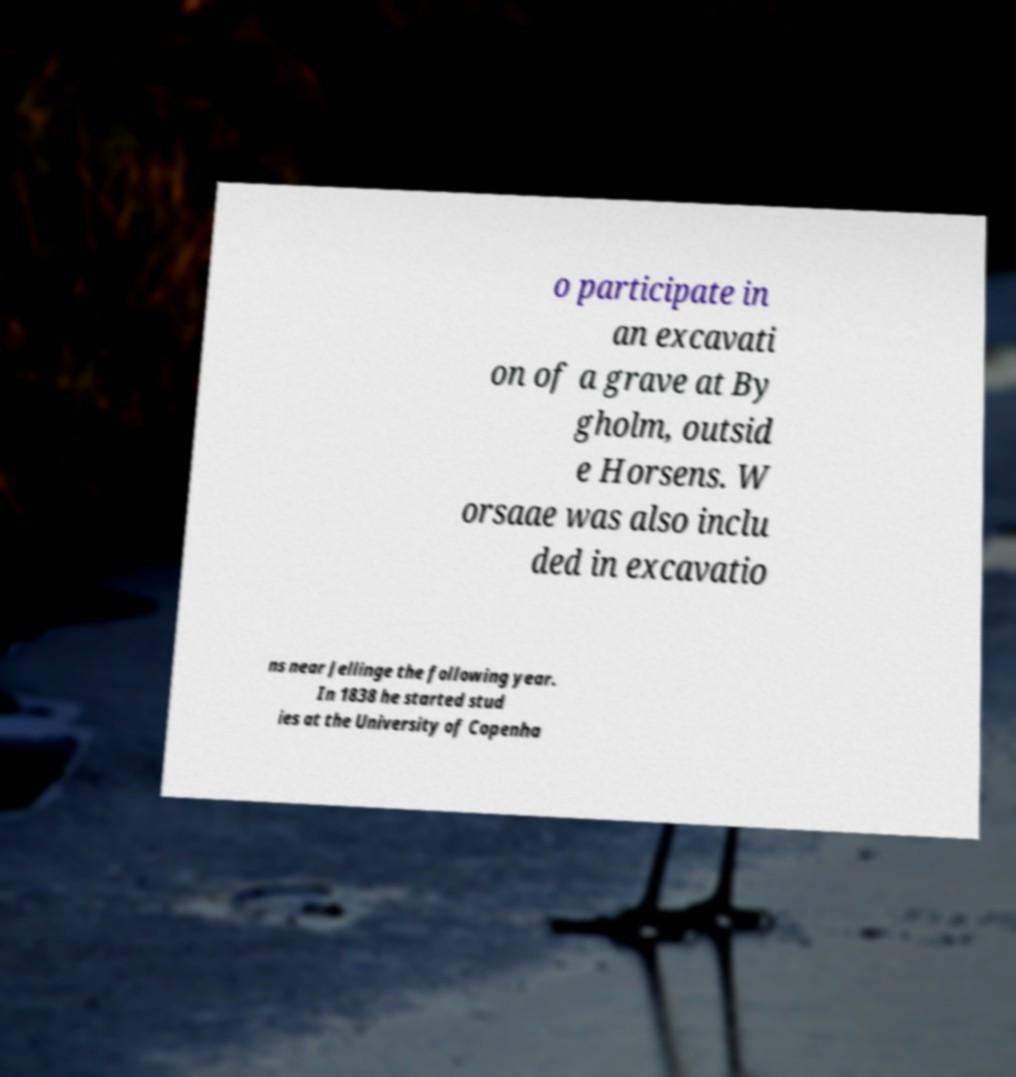Could you extract and type out the text from this image? o participate in an excavati on of a grave at By gholm, outsid e Horsens. W orsaae was also inclu ded in excavatio ns near Jellinge the following year. In 1838 he started stud ies at the University of Copenha 